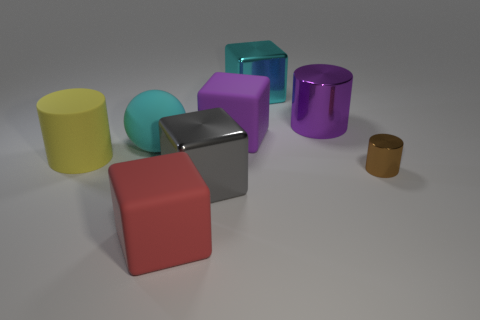Subtract all yellow cubes. Subtract all brown cylinders. How many cubes are left? 4 Add 2 red things. How many objects exist? 10 Subtract all spheres. How many objects are left? 7 Add 2 brown metallic cylinders. How many brown metallic cylinders exist? 3 Subtract 0 red spheres. How many objects are left? 8 Subtract all large metallic cylinders. Subtract all big yellow cylinders. How many objects are left? 6 Add 7 large purple cubes. How many large purple cubes are left? 8 